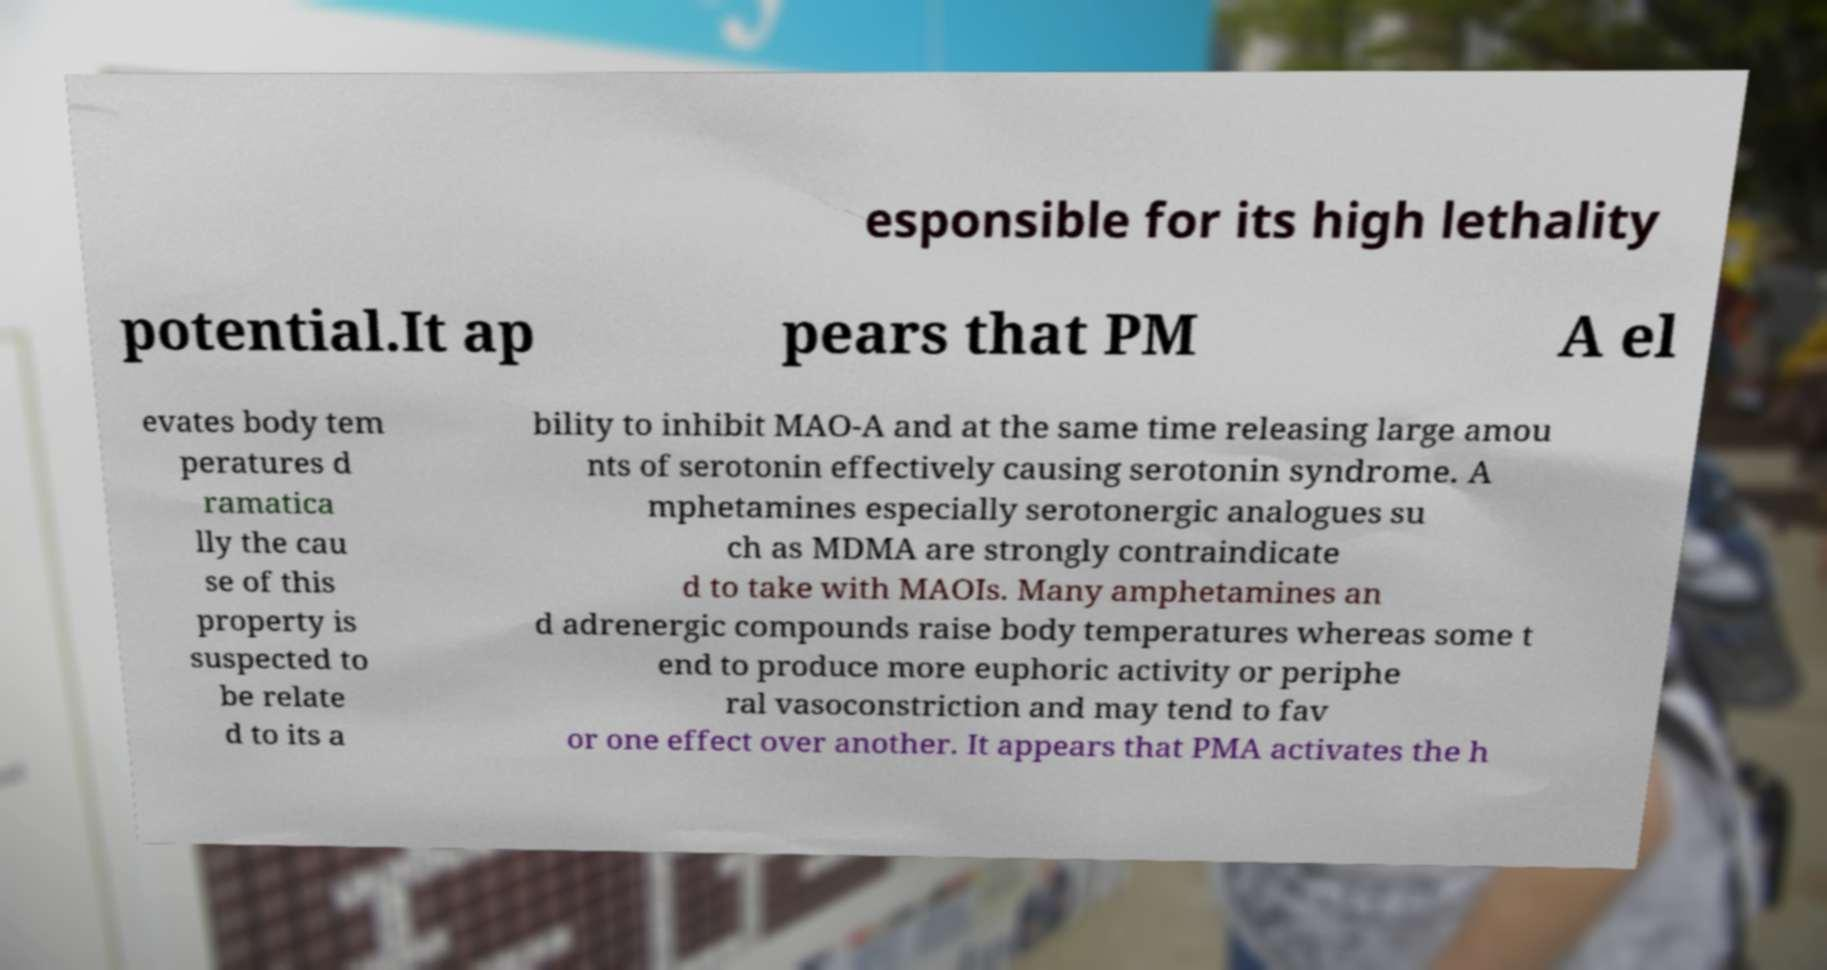For documentation purposes, I need the text within this image transcribed. Could you provide that? esponsible for its high lethality potential.It ap pears that PM A el evates body tem peratures d ramatica lly the cau se of this property is suspected to be relate d to its a bility to inhibit MAO-A and at the same time releasing large amou nts of serotonin effectively causing serotonin syndrome. A mphetamines especially serotonergic analogues su ch as MDMA are strongly contraindicate d to take with MAOIs. Many amphetamines an d adrenergic compounds raise body temperatures whereas some t end to produce more euphoric activity or periphe ral vasoconstriction and may tend to fav or one effect over another. It appears that PMA activates the h 